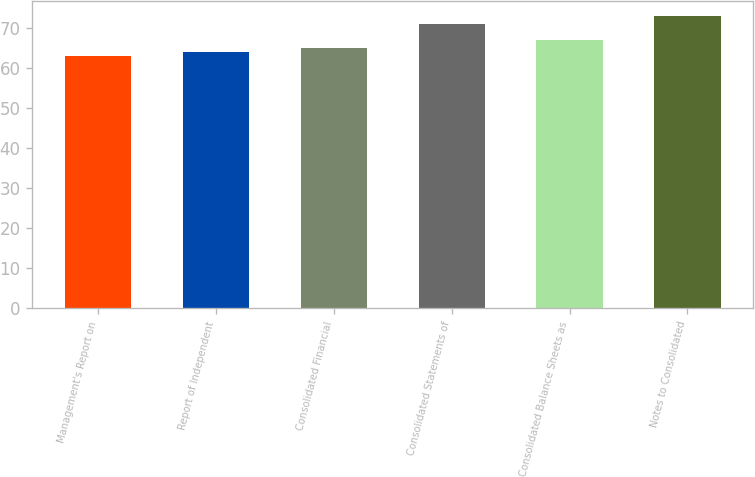Convert chart. <chart><loc_0><loc_0><loc_500><loc_500><bar_chart><fcel>Management's Report on<fcel>Report of Independent<fcel>Consolidated Financial<fcel>Consolidated Statements of<fcel>Consolidated Balance Sheets as<fcel>Notes to Consolidated<nl><fcel>63<fcel>64<fcel>65<fcel>71<fcel>67<fcel>73<nl></chart> 